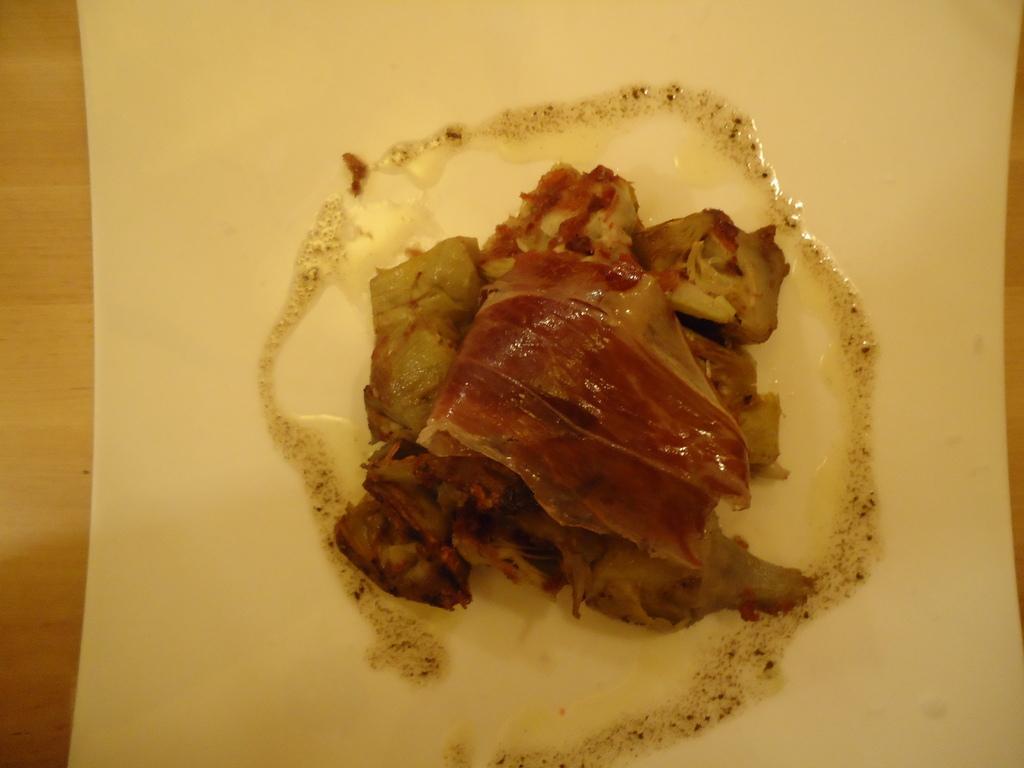Please provide a concise description of this image. In this image we can see a table. On the table there is a food item placed on a plate. 